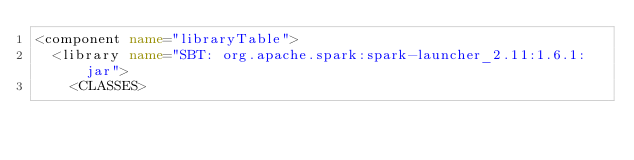<code> <loc_0><loc_0><loc_500><loc_500><_XML_><component name="libraryTable">
  <library name="SBT: org.apache.spark:spark-launcher_2.11:1.6.1:jar">
    <CLASSES></code> 